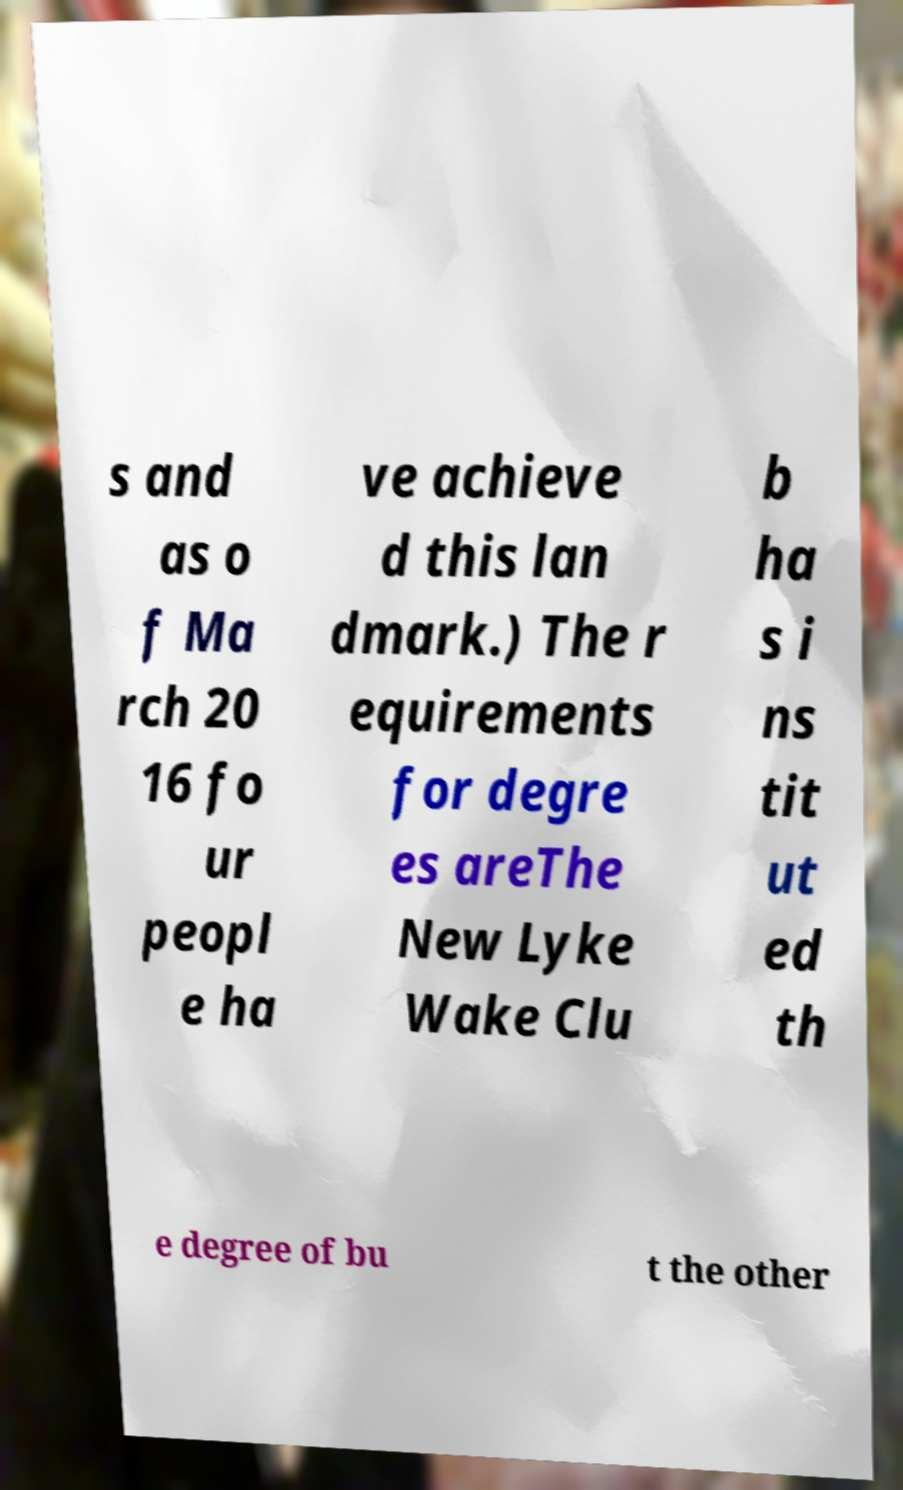There's text embedded in this image that I need extracted. Can you transcribe it verbatim? s and as o f Ma rch 20 16 fo ur peopl e ha ve achieve d this lan dmark.) The r equirements for degre es areThe New Lyke Wake Clu b ha s i ns tit ut ed th e degree of bu t the other 